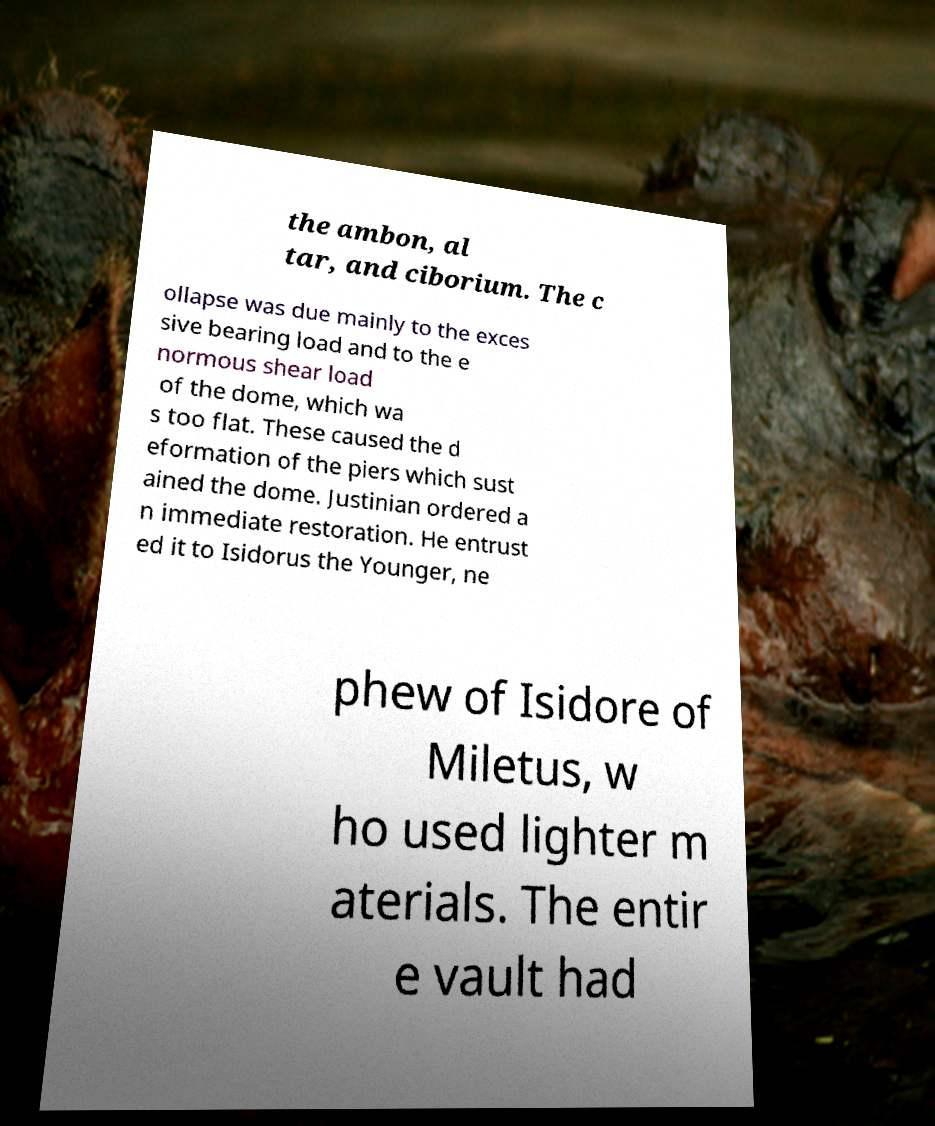There's text embedded in this image that I need extracted. Can you transcribe it verbatim? the ambon, al tar, and ciborium. The c ollapse was due mainly to the exces sive bearing load and to the e normous shear load of the dome, which wa s too flat. These caused the d eformation of the piers which sust ained the dome. Justinian ordered a n immediate restoration. He entrust ed it to Isidorus the Younger, ne phew of Isidore of Miletus, w ho used lighter m aterials. The entir e vault had 